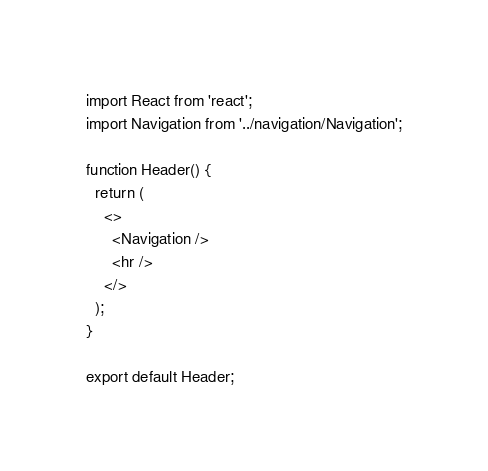<code> <loc_0><loc_0><loc_500><loc_500><_JavaScript_>import React from 'react';
import Navigation from '../navigation/Navigation';

function Header() {
  return (
    <>
      <Navigation />
      <hr />
    </>
  );
}

export default Header;
</code> 